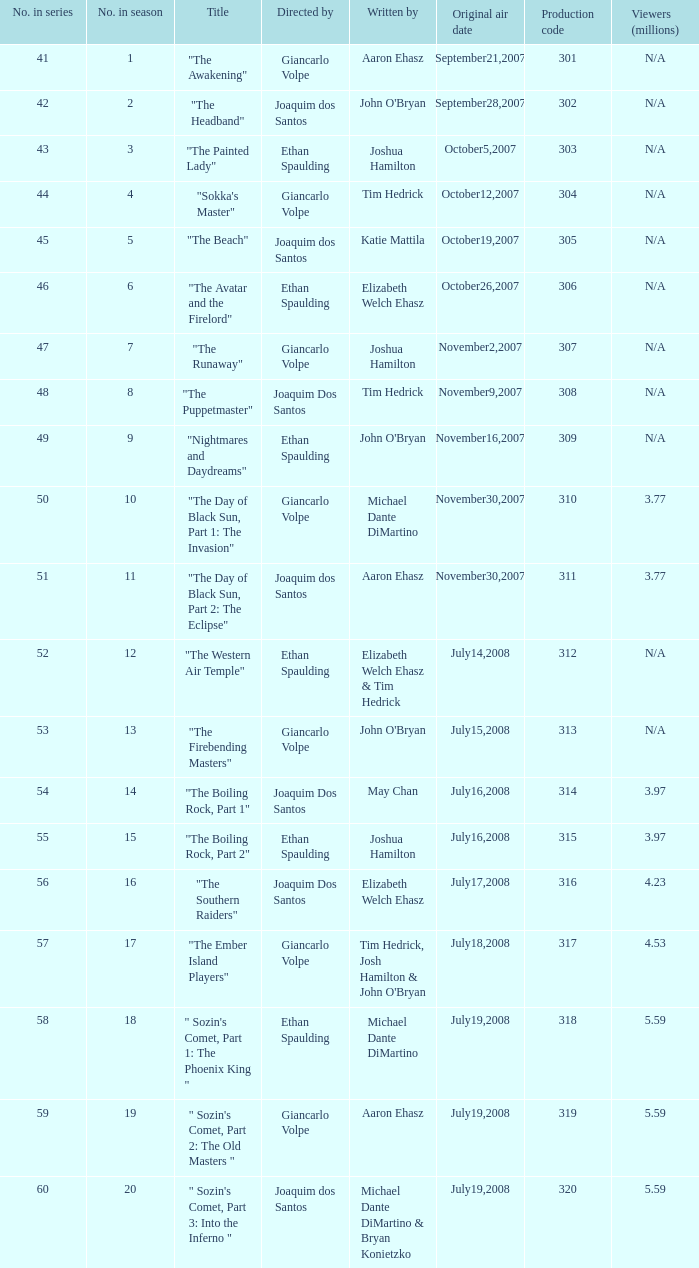What are all the numbers in the series with an episode title of "the beach"? 45.0. 